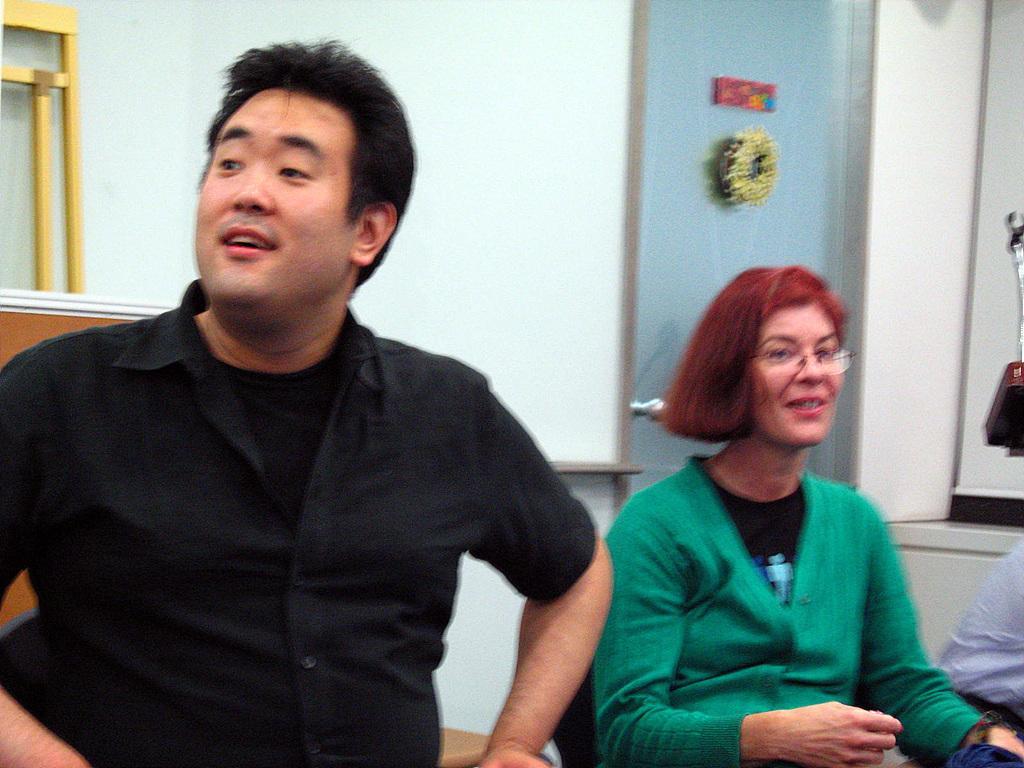How would you summarize this image in a sentence or two? This image consists of a man and a woman. The man is wearing a black dress. And the woman is wearing a green dress. In the background, there is a wall. 